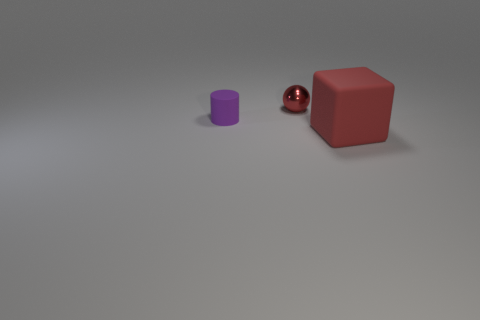Add 1 small blue shiny things. How many objects exist? 4 Subtract all cubes. How many objects are left? 2 Add 1 brown metal cylinders. How many brown metal cylinders exist? 1 Subtract 0 gray blocks. How many objects are left? 3 Subtract all small metallic balls. Subtract all big matte things. How many objects are left? 1 Add 1 small purple matte cylinders. How many small purple matte cylinders are left? 2 